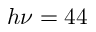Convert formula to latex. <formula><loc_0><loc_0><loc_500><loc_500>h \nu = 4 4</formula> 